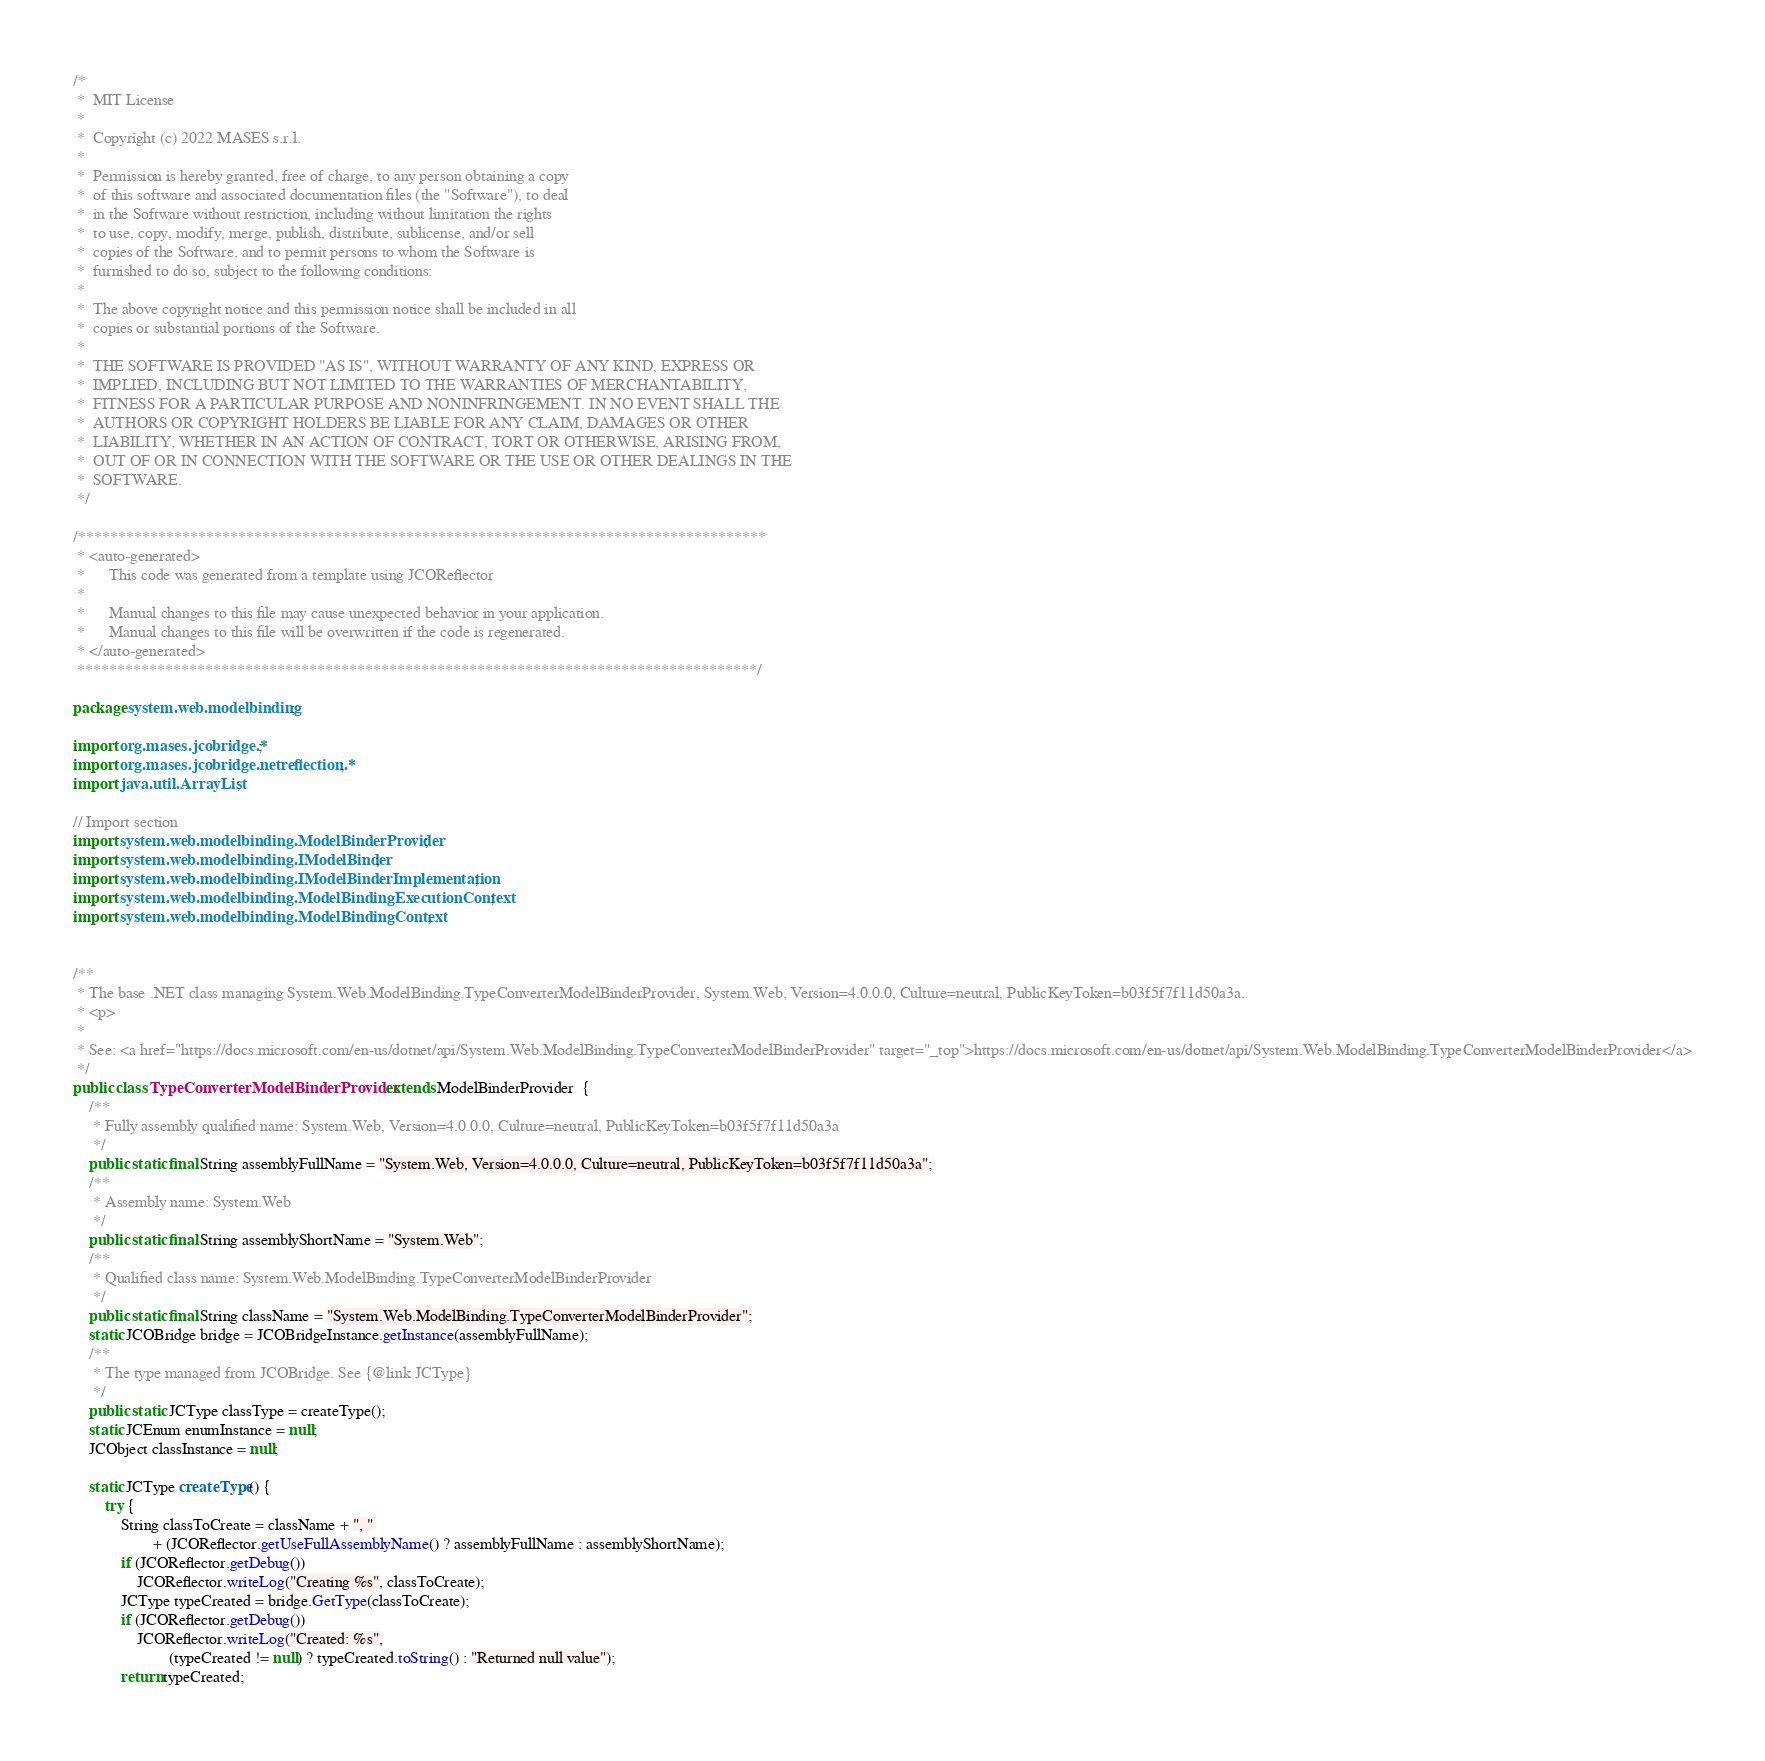Convert code to text. <code><loc_0><loc_0><loc_500><loc_500><_Java_>/*
 *  MIT License
 *
 *  Copyright (c) 2022 MASES s.r.l.
 *
 *  Permission is hereby granted, free of charge, to any person obtaining a copy
 *  of this software and associated documentation files (the "Software"), to deal
 *  in the Software without restriction, including without limitation the rights
 *  to use, copy, modify, merge, publish, distribute, sublicense, and/or sell
 *  copies of the Software, and to permit persons to whom the Software is
 *  furnished to do so, subject to the following conditions:
 *
 *  The above copyright notice and this permission notice shall be included in all
 *  copies or substantial portions of the Software.
 *
 *  THE SOFTWARE IS PROVIDED "AS IS", WITHOUT WARRANTY OF ANY KIND, EXPRESS OR
 *  IMPLIED, INCLUDING BUT NOT LIMITED TO THE WARRANTIES OF MERCHANTABILITY,
 *  FITNESS FOR A PARTICULAR PURPOSE AND NONINFRINGEMENT. IN NO EVENT SHALL THE
 *  AUTHORS OR COPYRIGHT HOLDERS BE LIABLE FOR ANY CLAIM, DAMAGES OR OTHER
 *  LIABILITY, WHETHER IN AN ACTION OF CONTRACT, TORT OR OTHERWISE, ARISING FROM,
 *  OUT OF OR IN CONNECTION WITH THE SOFTWARE OR THE USE OR OTHER DEALINGS IN THE
 *  SOFTWARE.
 */

/**************************************************************************************
 * <auto-generated>
 *      This code was generated from a template using JCOReflector
 * 
 *      Manual changes to this file may cause unexpected behavior in your application.
 *      Manual changes to this file will be overwritten if the code is regenerated.
 * </auto-generated>
 *************************************************************************************/

package system.web.modelbinding;

import org.mases.jcobridge.*;
import org.mases.jcobridge.netreflection.*;
import java.util.ArrayList;

// Import section
import system.web.modelbinding.ModelBinderProvider;
import system.web.modelbinding.IModelBinder;
import system.web.modelbinding.IModelBinderImplementation;
import system.web.modelbinding.ModelBindingExecutionContext;
import system.web.modelbinding.ModelBindingContext;


/**
 * The base .NET class managing System.Web.ModelBinding.TypeConverterModelBinderProvider, System.Web, Version=4.0.0.0, Culture=neutral, PublicKeyToken=b03f5f7f11d50a3a.
 * <p>
 * 
 * See: <a href="https://docs.microsoft.com/en-us/dotnet/api/System.Web.ModelBinding.TypeConverterModelBinderProvider" target="_top">https://docs.microsoft.com/en-us/dotnet/api/System.Web.ModelBinding.TypeConverterModelBinderProvider</a>
 */
public class TypeConverterModelBinderProvider extends ModelBinderProvider  {
    /**
     * Fully assembly qualified name: System.Web, Version=4.0.0.0, Culture=neutral, PublicKeyToken=b03f5f7f11d50a3a
     */
    public static final String assemblyFullName = "System.Web, Version=4.0.0.0, Culture=neutral, PublicKeyToken=b03f5f7f11d50a3a";
    /**
     * Assembly name: System.Web
     */
    public static final String assemblyShortName = "System.Web";
    /**
     * Qualified class name: System.Web.ModelBinding.TypeConverterModelBinderProvider
     */
    public static final String className = "System.Web.ModelBinding.TypeConverterModelBinderProvider";
    static JCOBridge bridge = JCOBridgeInstance.getInstance(assemblyFullName);
    /**
     * The type managed from JCOBridge. See {@link JCType}
     */
    public static JCType classType = createType();
    static JCEnum enumInstance = null;
    JCObject classInstance = null;

    static JCType createType() {
        try {
            String classToCreate = className + ", "
                    + (JCOReflector.getUseFullAssemblyName() ? assemblyFullName : assemblyShortName);
            if (JCOReflector.getDebug())
                JCOReflector.writeLog("Creating %s", classToCreate);
            JCType typeCreated = bridge.GetType(classToCreate);
            if (JCOReflector.getDebug())
                JCOReflector.writeLog("Created: %s",
                        (typeCreated != null) ? typeCreated.toString() : "Returned null value");
            return typeCreated;</code> 